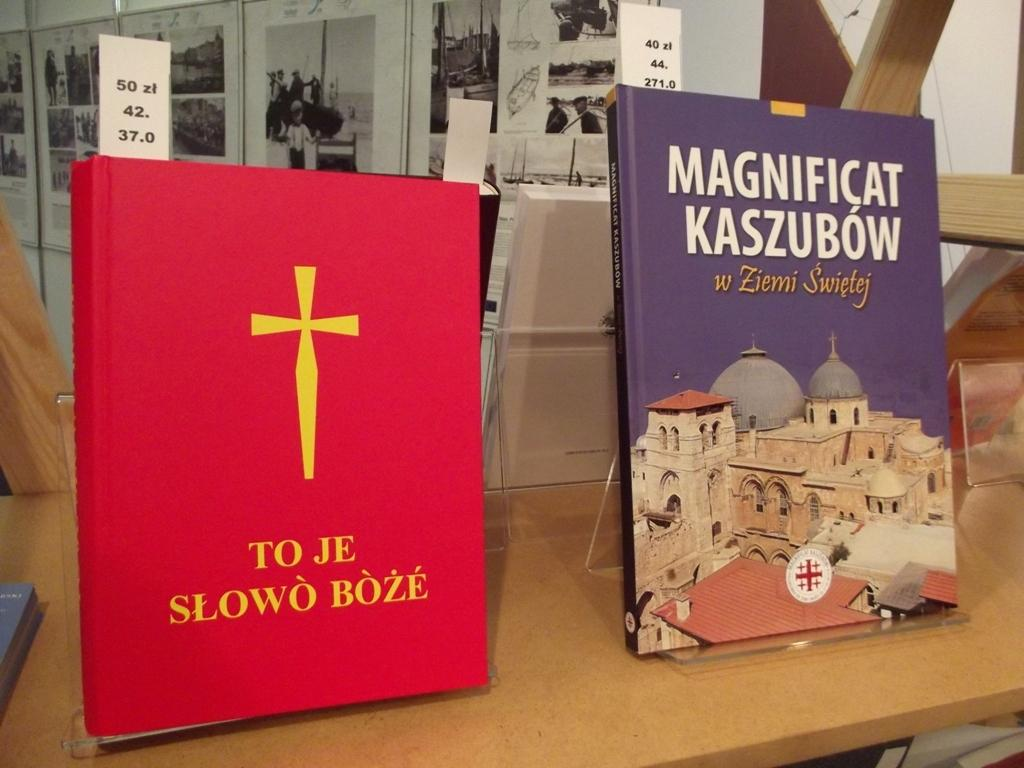<image>
Offer a succinct explanation of the picture presented. Two books in a foreign language sit atop a counter top.. 